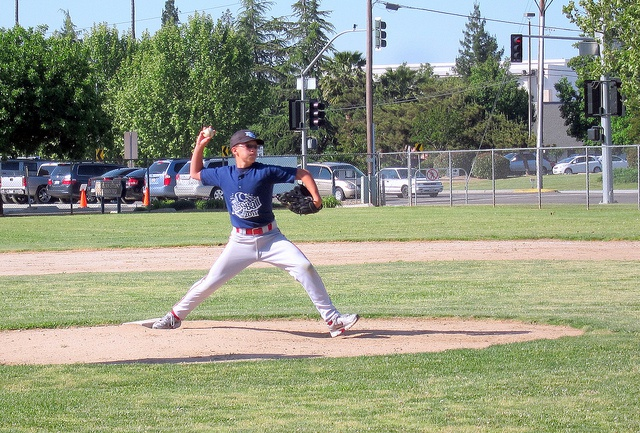Describe the objects in this image and their specific colors. I can see people in lightblue, lavender, darkgray, black, and blue tones, car in lightblue, black, gray, and navy tones, car in lightblue, darkgray, lightgray, and gray tones, car in lightblue, black, gray, and lavender tones, and car in lightblue, white, gray, and darkgray tones in this image. 